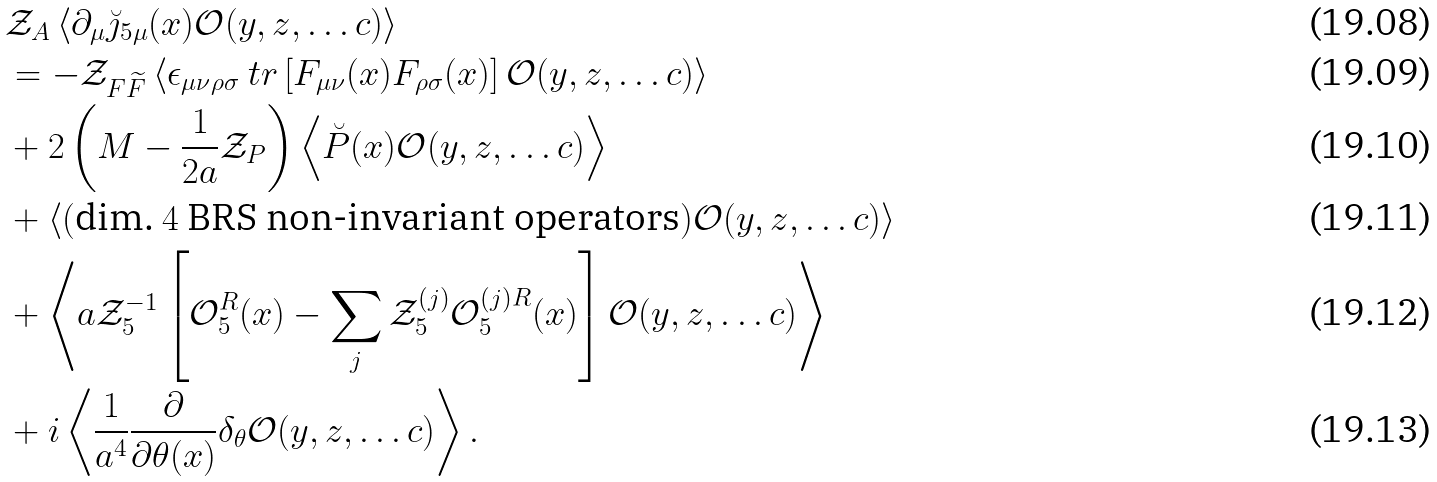Convert formula to latex. <formula><loc_0><loc_0><loc_500><loc_500>& \mathcal { Z } _ { A } \left \langle \partial _ { \mu } \breve { \jmath } _ { 5 \mu } ( x ) \mathcal { O } ( y , z , \dots c ) \right \rangle \\ & = - \mathcal { Z } _ { F \widetilde { F } } \left \langle \epsilon _ { \mu \nu \rho \sigma } \ t r \left [ F _ { \mu \nu } ( x ) F _ { \rho \sigma } ( x ) \right ] \mathcal { O } ( y , z , \dots c ) \right \rangle \\ & + 2 \left ( M - \frac { 1 } { 2 a } \mathcal { Z } _ { P } \right ) \left \langle \breve { P } ( x ) \mathcal { O } ( y , z , \dots c ) \right \rangle \\ & + \left \langle ( \text {dim.\ $4$ BRS non-invariant operators} ) \mathcal { O } ( y , z , \dots c ) \right \rangle \\ & + \left \langle a \mathcal { Z } _ { 5 } ^ { - 1 } \left [ \mathcal { O } _ { 5 } ^ { R } ( x ) - \sum _ { j } \mathcal { Z } _ { 5 } ^ { ( j ) } \mathcal { O } _ { 5 } ^ { ( j ) R } ( x ) \right ] \mathcal { O } ( y , z , \dots c ) \right \rangle \\ & + i \left \langle \frac { 1 } { a ^ { 4 } } \frac { \partial } { \partial \theta ( x ) } \delta _ { \theta } \mathcal { O } ( y , z , \dots c ) \right \rangle .</formula> 